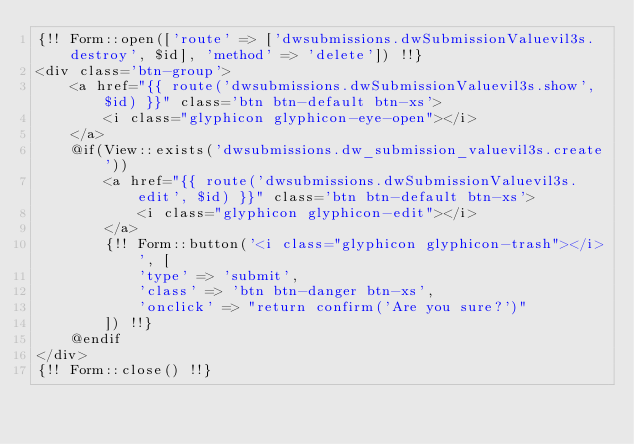<code> <loc_0><loc_0><loc_500><loc_500><_PHP_>{!! Form::open(['route' => ['dwsubmissions.dwSubmissionValuevil3s.destroy', $id], 'method' => 'delete']) !!}
<div class='btn-group'>
    <a href="{{ route('dwsubmissions.dwSubmissionValuevil3s.show', $id) }}" class='btn btn-default btn-xs'>
        <i class="glyphicon glyphicon-eye-open"></i>
    </a>
    @if(View::exists('dwsubmissions.dw_submission_valuevil3s.create'))
        <a href="{{ route('dwsubmissions.dwSubmissionValuevil3s.edit', $id) }}" class='btn btn-default btn-xs'>
            <i class="glyphicon glyphicon-edit"></i>
        </a>
        {!! Form::button('<i class="glyphicon glyphicon-trash"></i>', [
            'type' => 'submit',
            'class' => 'btn btn-danger btn-xs',
            'onclick' => "return confirm('Are you sure?')"
        ]) !!}
    @endif
</div>
{!! Form::close() !!}
</code> 